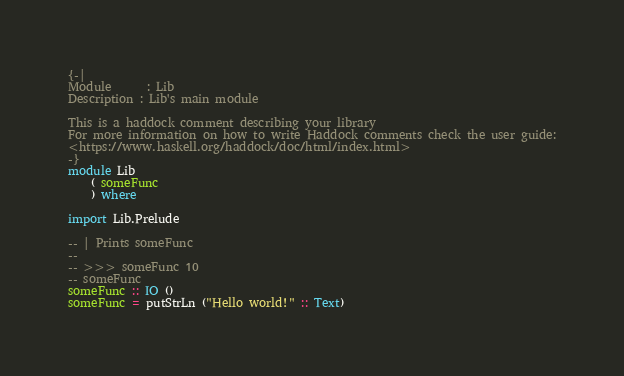Convert code to text. <code><loc_0><loc_0><loc_500><loc_500><_Haskell_>{-|
Module      : Lib
Description : Lib's main module

This is a haddock comment describing your library
For more information on how to write Haddock comments check the user guide:
<https://www.haskell.org/haddock/doc/html/index.html>
-}
module Lib
    ( someFunc
    ) where

import Lib.Prelude

-- | Prints someFunc
--
-- >>> someFunc 10
-- someFunc
someFunc :: IO ()
someFunc = putStrLn ("Hello world!" :: Text)
</code> 